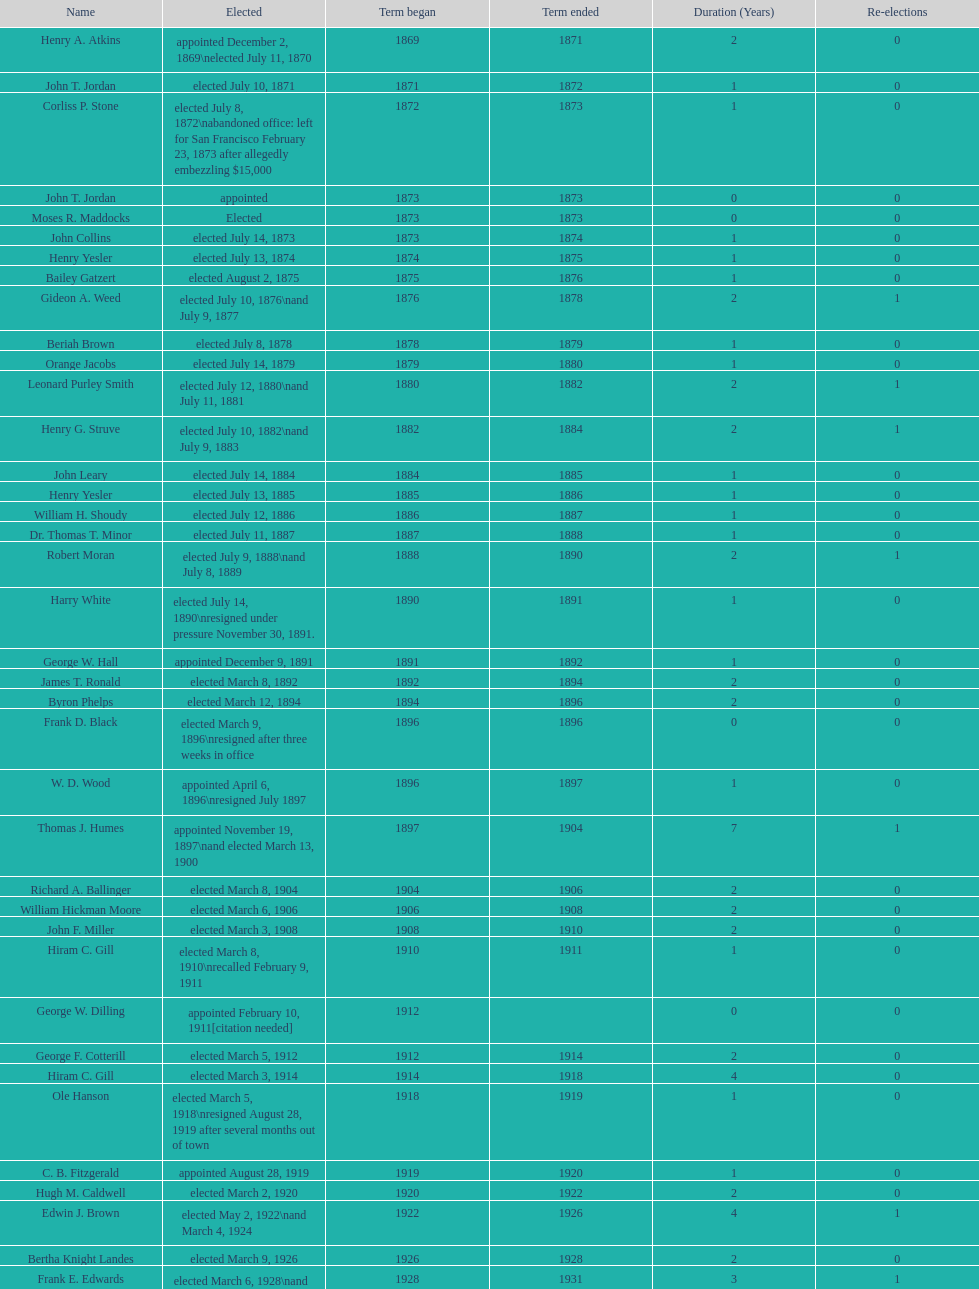How many women have been elected mayor of seattle, washington? 1. 